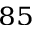<formula> <loc_0><loc_0><loc_500><loc_500>^ { 8 5 }</formula> 